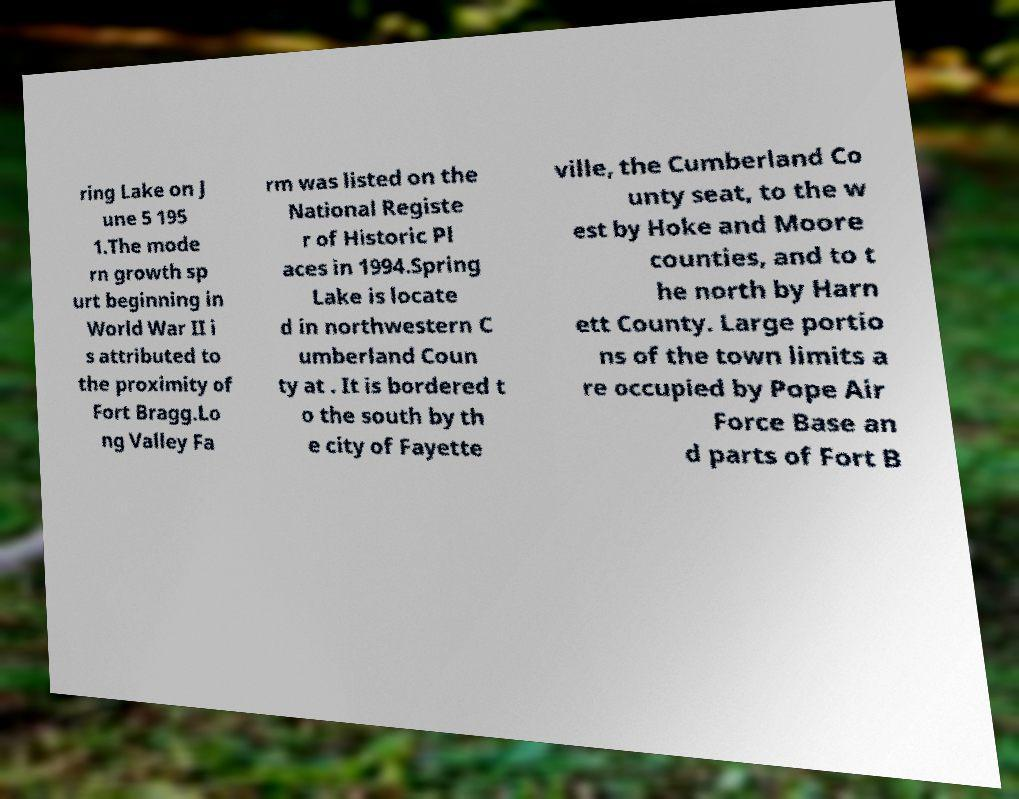Can you accurately transcribe the text from the provided image for me? ring Lake on J une 5 195 1.The mode rn growth sp urt beginning in World War II i s attributed to the proximity of Fort Bragg.Lo ng Valley Fa rm was listed on the National Registe r of Historic Pl aces in 1994.Spring Lake is locate d in northwestern C umberland Coun ty at . It is bordered t o the south by th e city of Fayette ville, the Cumberland Co unty seat, to the w est by Hoke and Moore counties, and to t he north by Harn ett County. Large portio ns of the town limits a re occupied by Pope Air Force Base an d parts of Fort B 